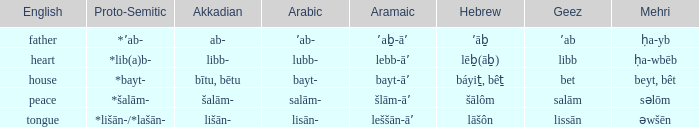If in arabic it is salām-, what is it in proto-semitic? *šalām-. 